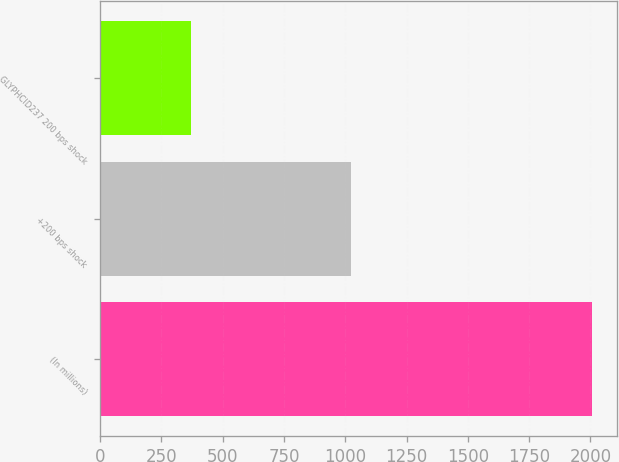Convert chart to OTSL. <chart><loc_0><loc_0><loc_500><loc_500><bar_chart><fcel>(In millions)<fcel>+200 bps shock<fcel>GLYPHCID237 200 bps shock<nl><fcel>2006<fcel>1023<fcel>371<nl></chart> 